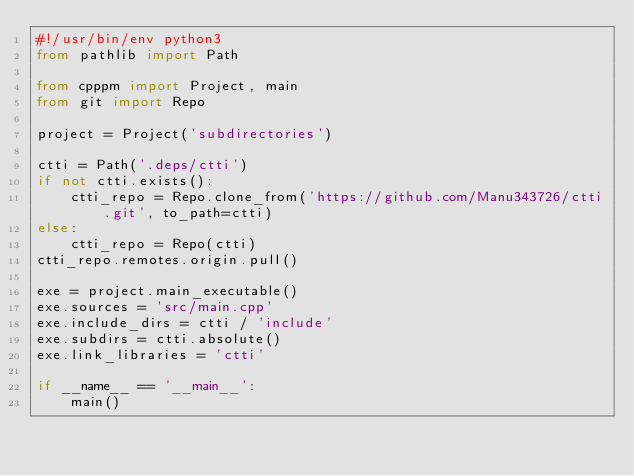<code> <loc_0><loc_0><loc_500><loc_500><_Python_>#!/usr/bin/env python3
from pathlib import Path

from cpppm import Project, main
from git import Repo

project = Project('subdirectories')

ctti = Path('.deps/ctti')
if not ctti.exists():
    ctti_repo = Repo.clone_from('https://github.com/Manu343726/ctti.git', to_path=ctti)
else:
    ctti_repo = Repo(ctti)
ctti_repo.remotes.origin.pull()

exe = project.main_executable()
exe.sources = 'src/main.cpp'
exe.include_dirs = ctti / 'include'
exe.subdirs = ctti.absolute()
exe.link_libraries = 'ctti'

if __name__ == '__main__':
    main()
</code> 